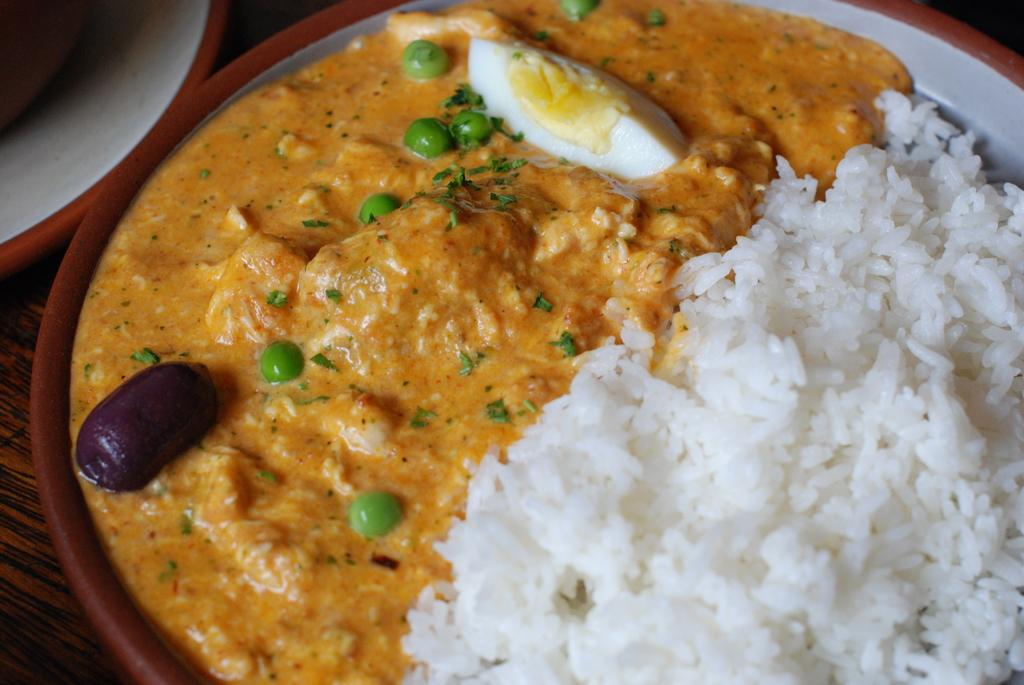What is present on the plate in the image? There is food in a plate in the image. What decision does the zebra make during its journey in the image? There is no zebra or journey present in the image; it only features a plate of food. 